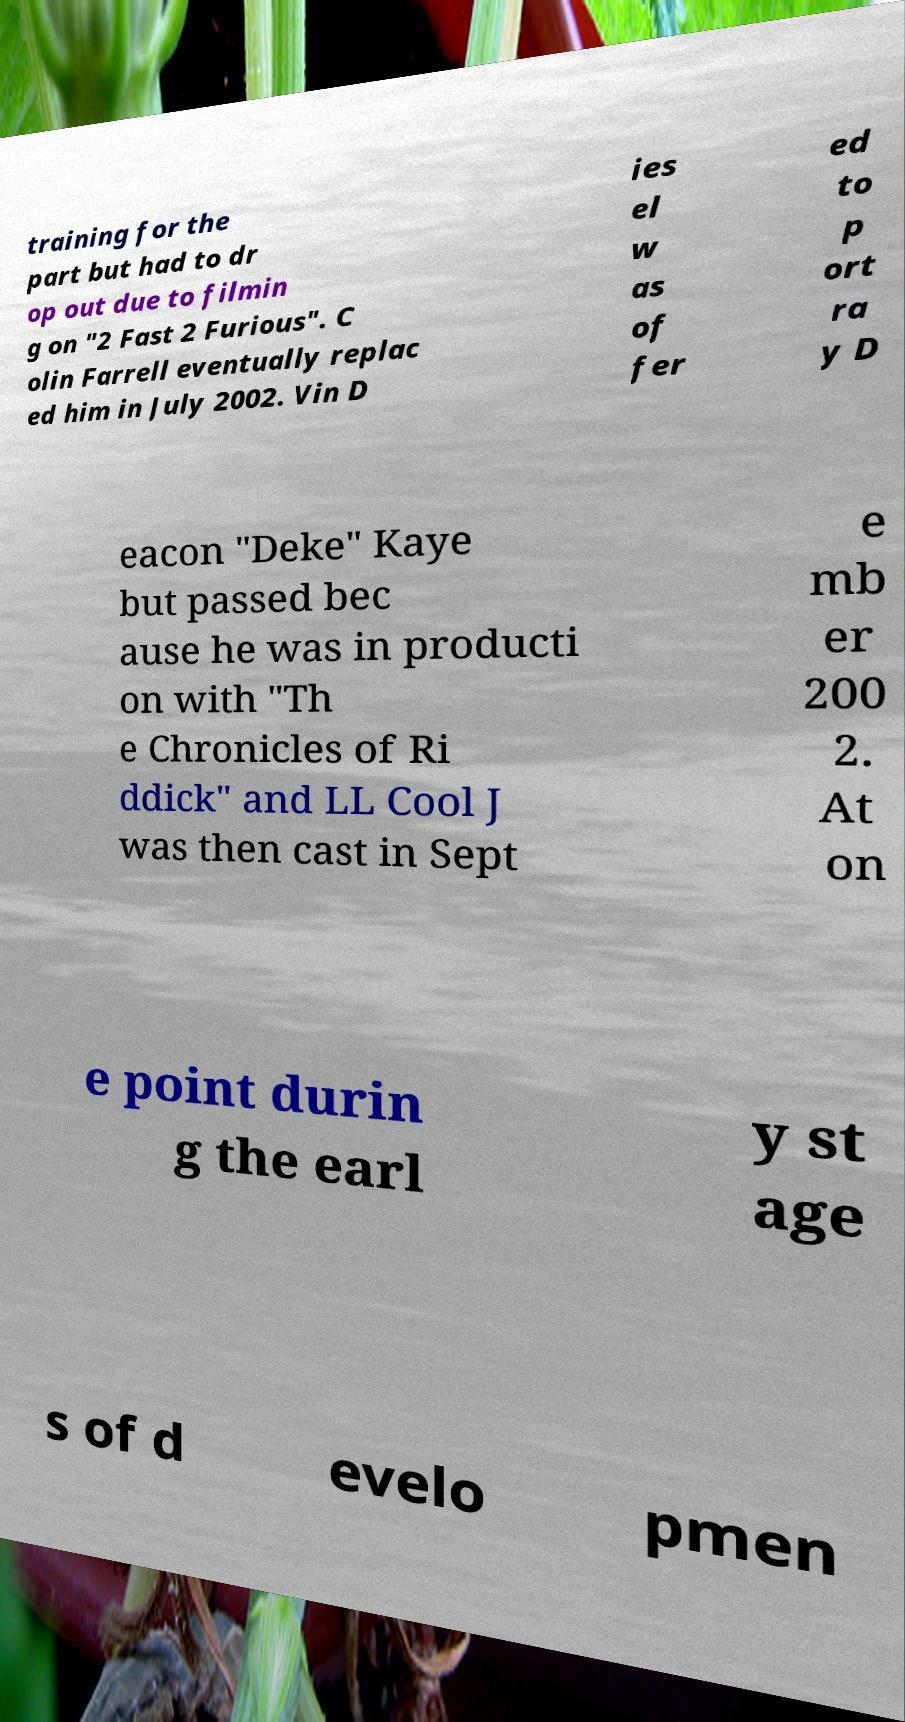Can you accurately transcribe the text from the provided image for me? training for the part but had to dr op out due to filmin g on "2 Fast 2 Furious". C olin Farrell eventually replac ed him in July 2002. Vin D ies el w as of fer ed to p ort ra y D eacon "Deke" Kaye but passed bec ause he was in producti on with "Th e Chronicles of Ri ddick" and LL Cool J was then cast in Sept e mb er 200 2. At on e point durin g the earl y st age s of d evelo pmen 